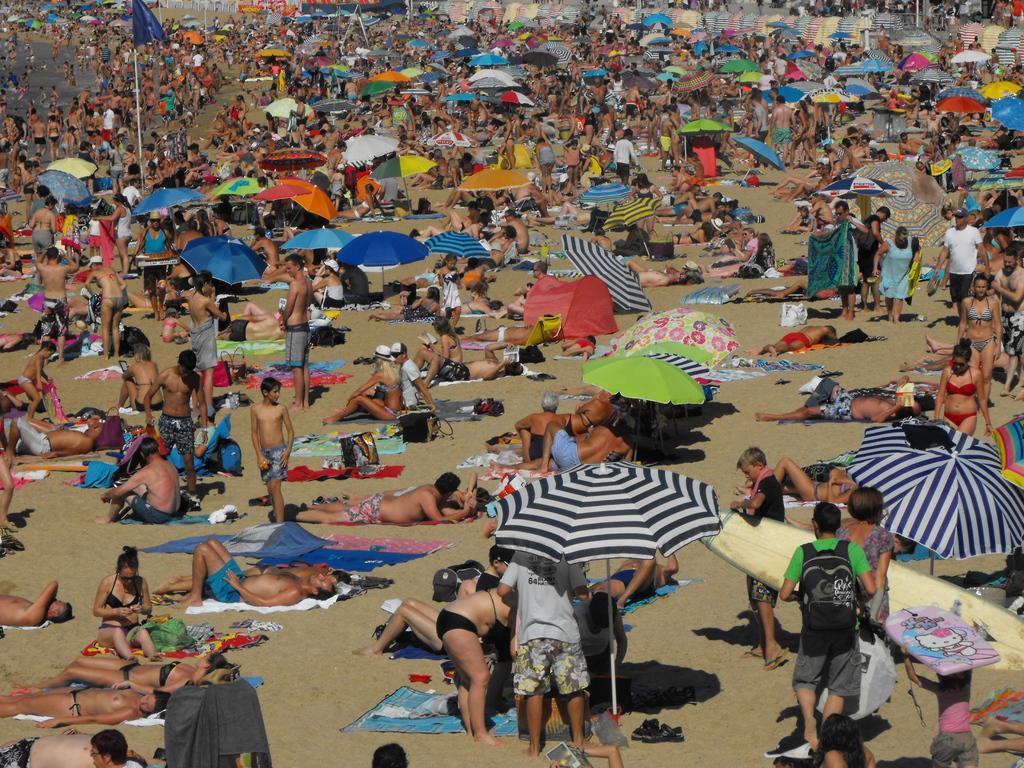Can you describe this image briefly? This is a beach. In this image I can see a crowd of people sitting and standing. Many people are lying under the umbrellas. In the bottom right-hand corner there is a person holding surfboard in the hands. In the top left-hand corner, I can see the water. There are few people in the water and also there is a blue color flag. 